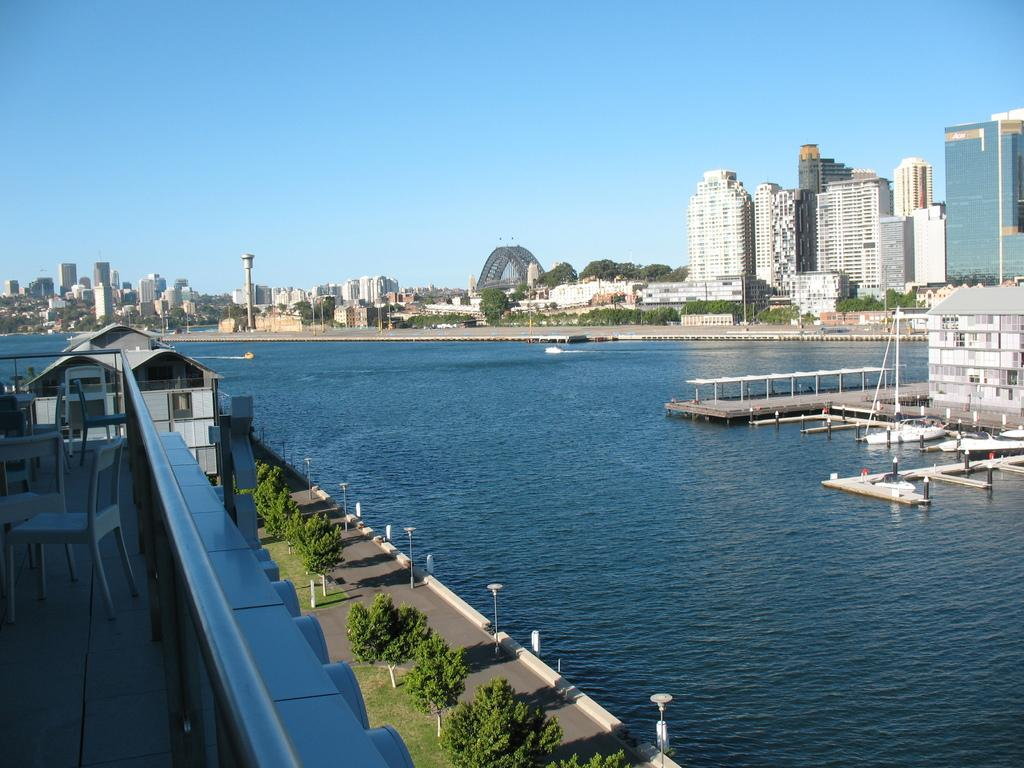What is the primary feature of the image? There is a water surface in the image. What else can be seen in the image besides the water surface? There are plants, buildings on the right side, buildings on the left side, and buildings in the background of the image. What type of oven can be seen in the image? There is no oven present in the image. How does the sun affect the plants in the image? The image does not show the sun, so its effect on the plants cannot be determined. 